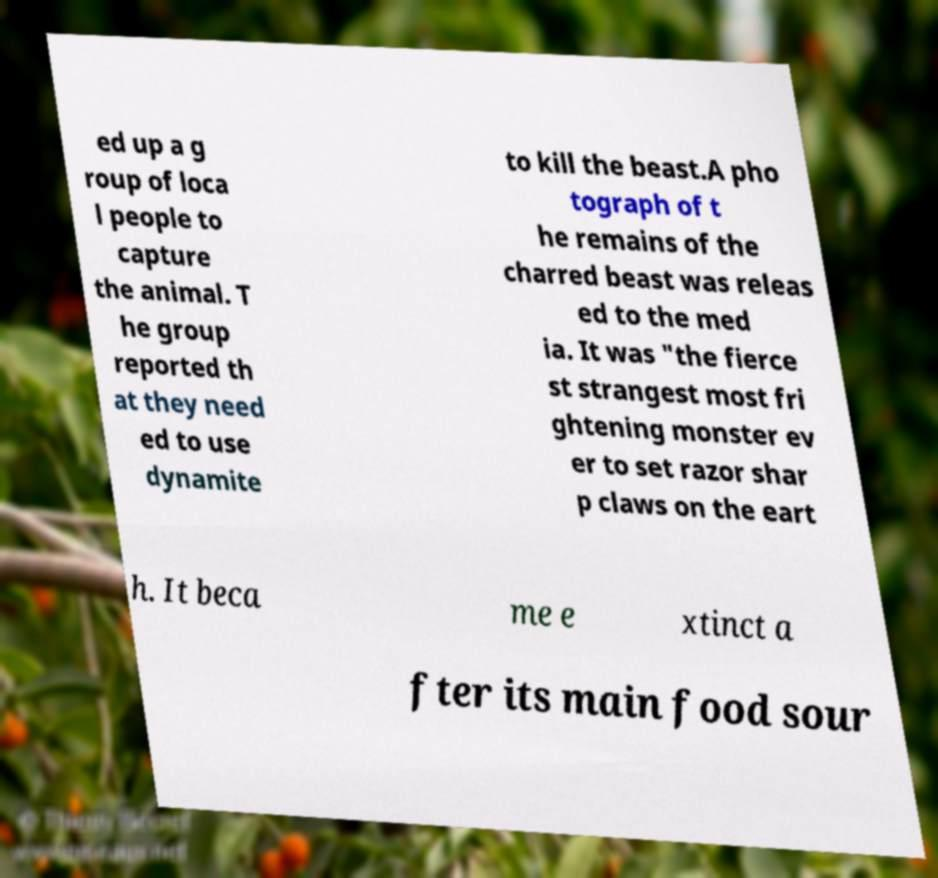For documentation purposes, I need the text within this image transcribed. Could you provide that? ed up a g roup of loca l people to capture the animal. T he group reported th at they need ed to use dynamite to kill the beast.A pho tograph of t he remains of the charred beast was releas ed to the med ia. It was "the fierce st strangest most fri ghtening monster ev er to set razor shar p claws on the eart h. It beca me e xtinct a fter its main food sour 